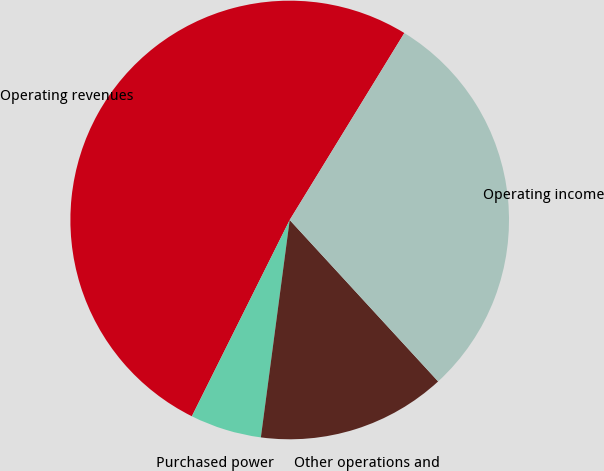<chart> <loc_0><loc_0><loc_500><loc_500><pie_chart><fcel>Operating revenues<fcel>Purchased power<fcel>Other operations and<fcel>Operating income<nl><fcel>51.39%<fcel>5.26%<fcel>13.93%<fcel>29.41%<nl></chart> 